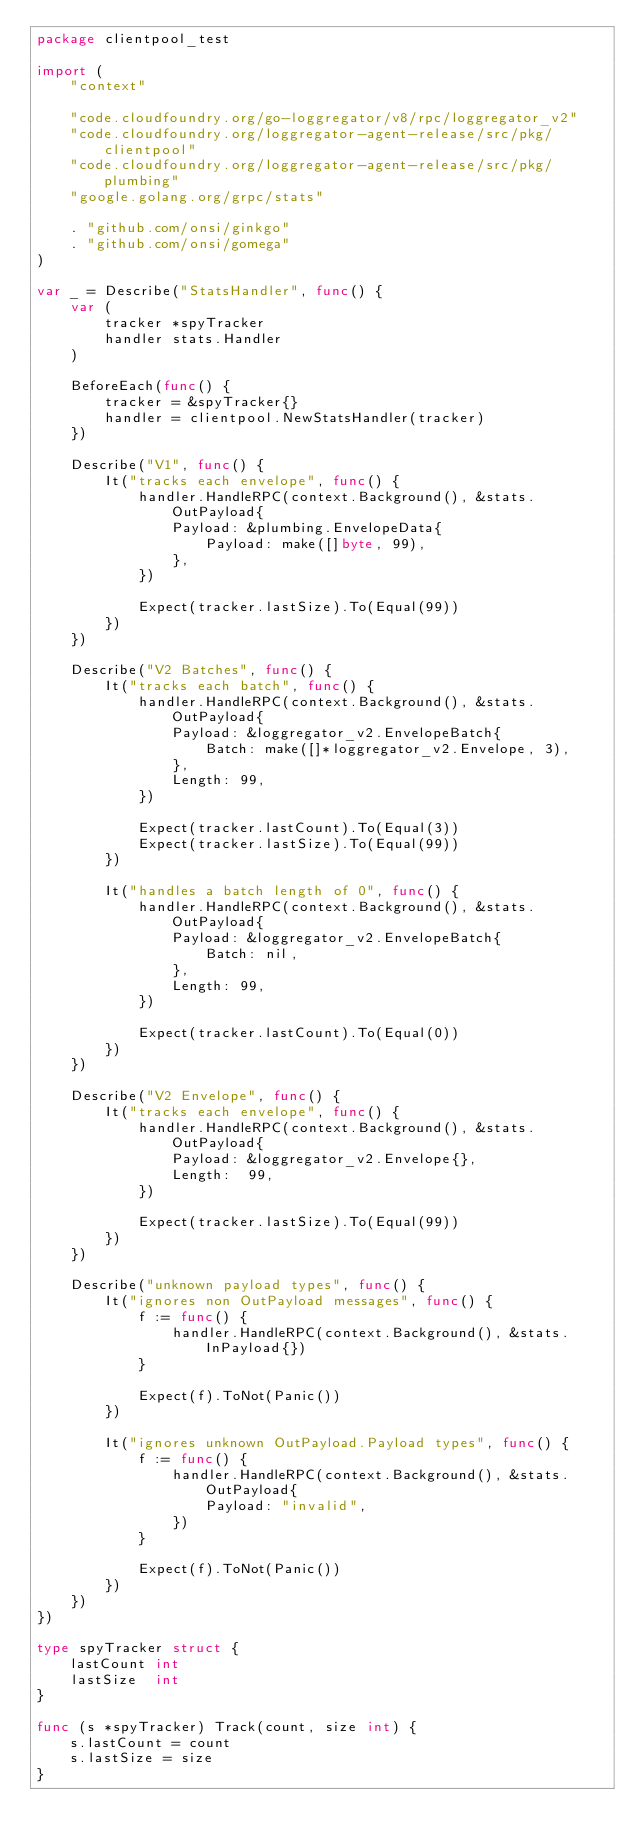<code> <loc_0><loc_0><loc_500><loc_500><_Go_>package clientpool_test

import (
	"context"

	"code.cloudfoundry.org/go-loggregator/v8/rpc/loggregator_v2"
	"code.cloudfoundry.org/loggregator-agent-release/src/pkg/clientpool"
	"code.cloudfoundry.org/loggregator-agent-release/src/pkg/plumbing"
	"google.golang.org/grpc/stats"

	. "github.com/onsi/ginkgo"
	. "github.com/onsi/gomega"
)

var _ = Describe("StatsHandler", func() {
	var (
		tracker *spyTracker
		handler stats.Handler
	)

	BeforeEach(func() {
		tracker = &spyTracker{}
		handler = clientpool.NewStatsHandler(tracker)
	})

	Describe("V1", func() {
		It("tracks each envelope", func() {
			handler.HandleRPC(context.Background(), &stats.OutPayload{
				Payload: &plumbing.EnvelopeData{
					Payload: make([]byte, 99),
				},
			})

			Expect(tracker.lastSize).To(Equal(99))
		})
	})

	Describe("V2 Batches", func() {
		It("tracks each batch", func() {
			handler.HandleRPC(context.Background(), &stats.OutPayload{
				Payload: &loggregator_v2.EnvelopeBatch{
					Batch: make([]*loggregator_v2.Envelope, 3),
				},
				Length: 99,
			})

			Expect(tracker.lastCount).To(Equal(3))
			Expect(tracker.lastSize).To(Equal(99))
		})

		It("handles a batch length of 0", func() {
			handler.HandleRPC(context.Background(), &stats.OutPayload{
				Payload: &loggregator_v2.EnvelopeBatch{
					Batch: nil,
				},
				Length: 99,
			})

			Expect(tracker.lastCount).To(Equal(0))
		})
	})

	Describe("V2 Envelope", func() {
		It("tracks each envelope", func() {
			handler.HandleRPC(context.Background(), &stats.OutPayload{
				Payload: &loggregator_v2.Envelope{},
				Length:  99,
			})

			Expect(tracker.lastSize).To(Equal(99))
		})
	})

	Describe("unknown payload types", func() {
		It("ignores non OutPayload messages", func() {
			f := func() {
				handler.HandleRPC(context.Background(), &stats.InPayload{})
			}

			Expect(f).ToNot(Panic())
		})

		It("ignores unknown OutPayload.Payload types", func() {
			f := func() {
				handler.HandleRPC(context.Background(), &stats.OutPayload{
					Payload: "invalid",
				})
			}

			Expect(f).ToNot(Panic())
		})
	})
})

type spyTracker struct {
	lastCount int
	lastSize  int
}

func (s *spyTracker) Track(count, size int) {
	s.lastCount = count
	s.lastSize = size
}
</code> 